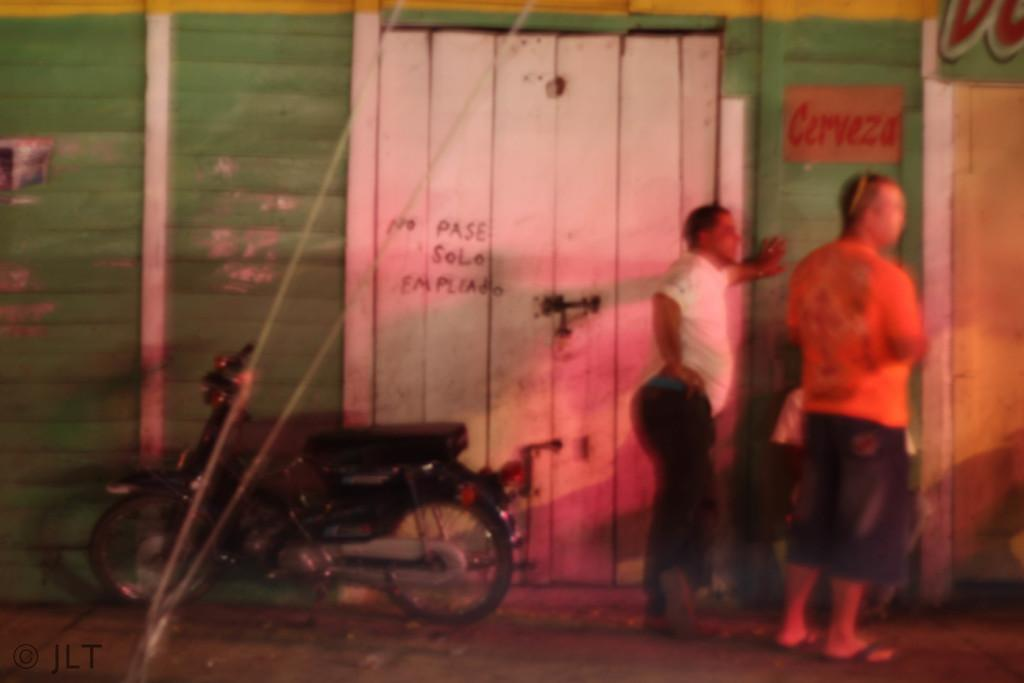What is the main object in the image? There is a bike in the image. Who or what else is present in the image? Two men are standing on the road in the image. What can be seen in the background of the image? There is a wooden wall and a door in the background of the image. What type of zinc material is used to construct the bike in the image? The bike in the image is not made of zinc; it is made of other materials such as metal or plastic. Can you see a cannon in the image? No, there is no cannon present in the image. 